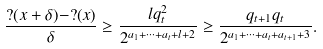<formula> <loc_0><loc_0><loc_500><loc_500>\frac { ? ( x + \delta ) - ? ( x ) } { \delta } \geq \frac { l q _ { t } ^ { 2 } } { 2 ^ { a _ { 1 } + \dots + a _ { t } + l + 2 } } \geq \frac { q _ { t + 1 } q _ { t } } { 2 ^ { a _ { 1 } + \dots + a _ { t } + a _ { t + 1 } + 3 } } .</formula> 